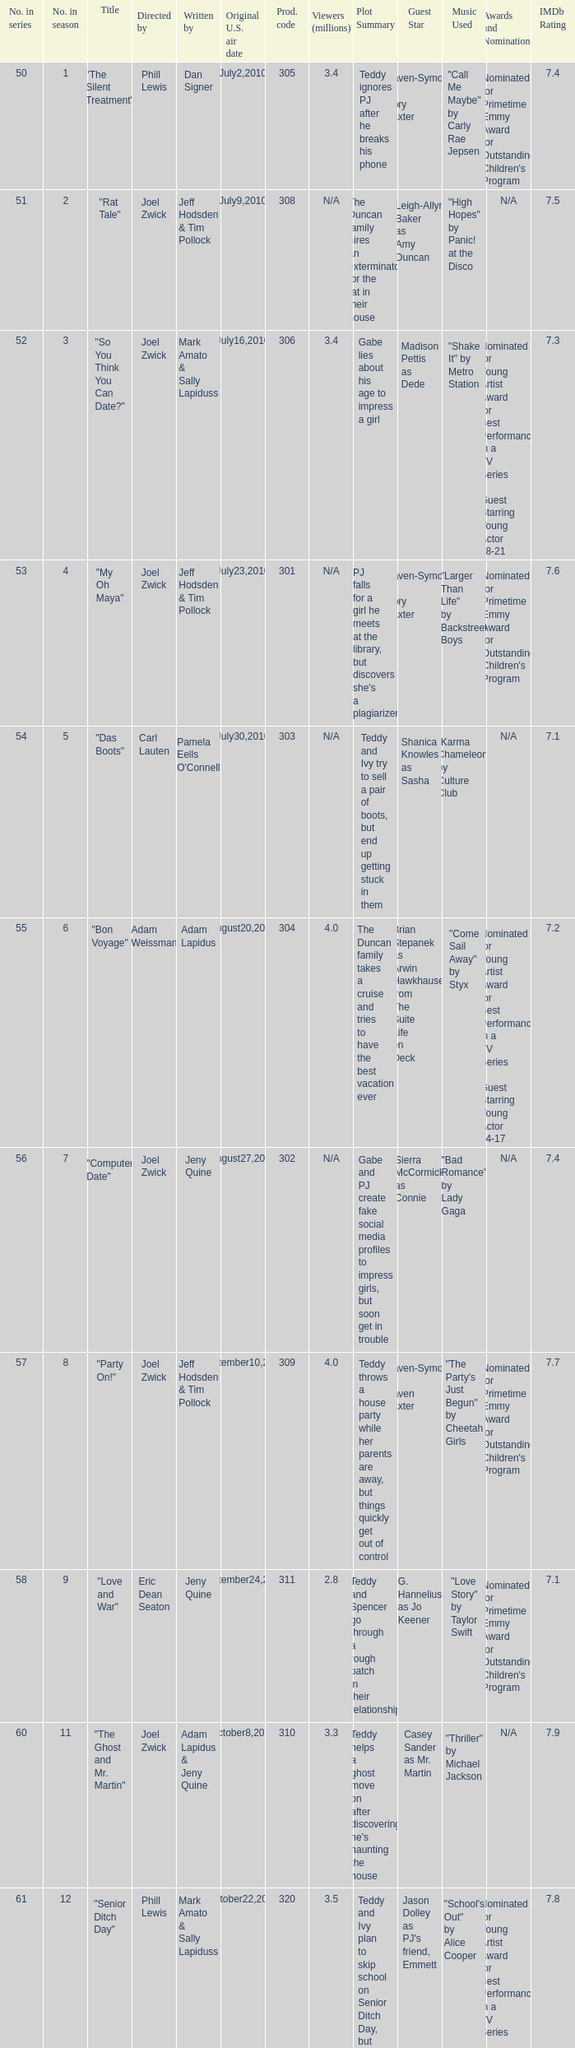How many million viewers watched episode 6? 4.0. 